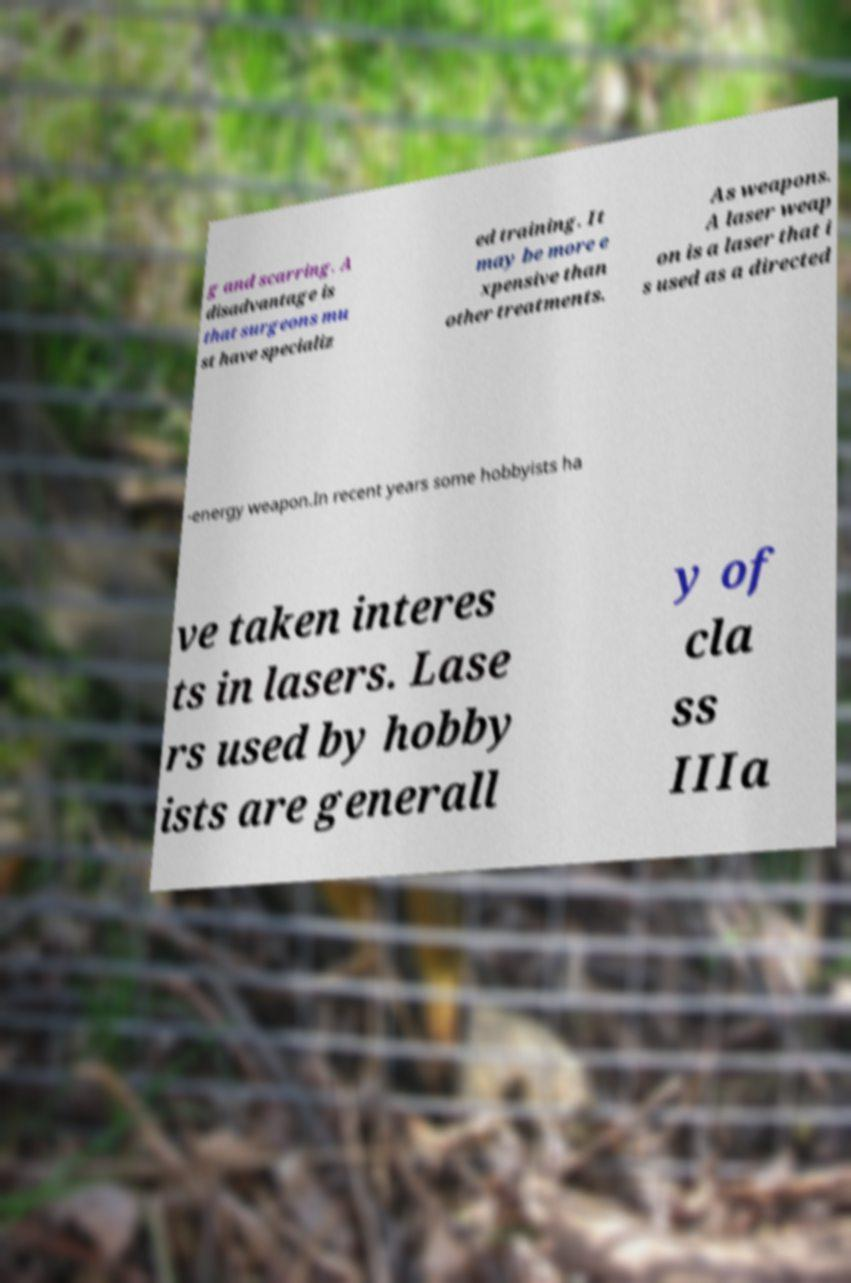Could you extract and type out the text from this image? g and scarring. A disadvantage is that surgeons mu st have specializ ed training. It may be more e xpensive than other treatments. As weapons. A laser weap on is a laser that i s used as a directed -energy weapon.In recent years some hobbyists ha ve taken interes ts in lasers. Lase rs used by hobby ists are generall y of cla ss IIIa 